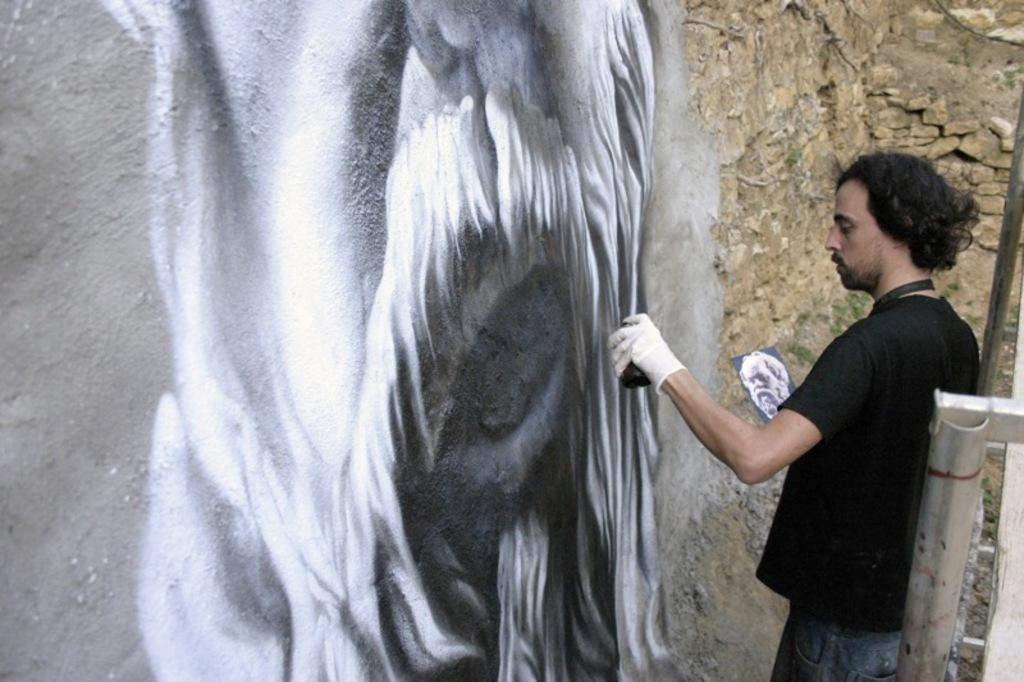What is the man in the image doing? The man is painting a picture on the wall. What tool is the man using to paint? The man is using a spray to paint. How is the man holding the picture while painting? The man is holding the picture with one hand. What can be seen on the right side of the image? There is a metal rod on the right side of the image. Can you tell me how many toys are present in the image? There are no toys present in the image. What type of society is depicted in the image? The image does not depict a society; it shows a man painting a picture on the wall. 